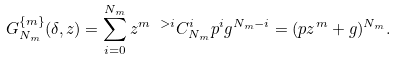<formula> <loc_0><loc_0><loc_500><loc_500>G _ { N _ { m } } ^ { \{ m \} } ( \delta , z ) = \sum _ { i = 0 } ^ { N _ { m } } z ^ { m \ > i } C _ { N _ { m } } ^ { i } p ^ { i } g ^ { N _ { m } - i } = ( p z ^ { m } + g ) ^ { N _ { m } } .</formula> 